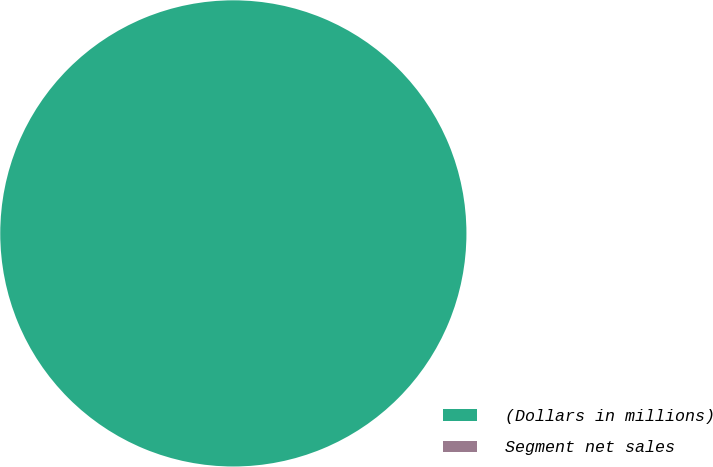Convert chart to OTSL. <chart><loc_0><loc_0><loc_500><loc_500><pie_chart><fcel>(Dollars in millions)<fcel>Segment net sales<nl><fcel>100.0%<fcel>0.0%<nl></chart> 